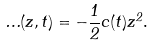Convert formula to latex. <formula><loc_0><loc_0><loc_500><loc_500>\Phi ( z , t ) = - \frac { 1 } { 2 } c ( t ) z ^ { 2 } .</formula> 